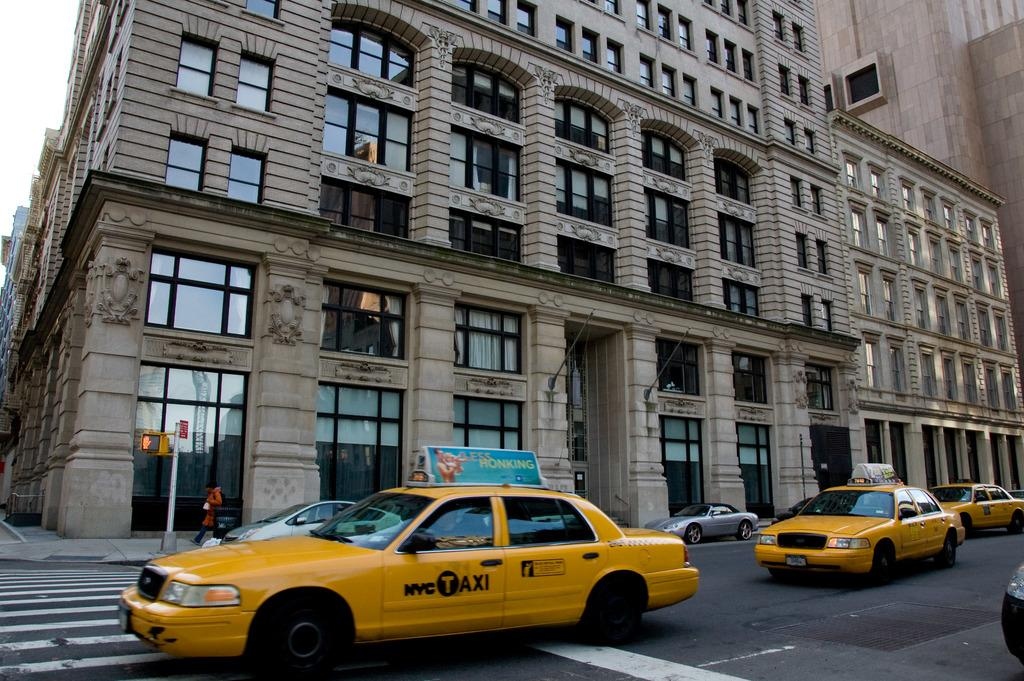<image>
Render a clear and concise summary of the photo. a Taxi with the letter t covered by black 